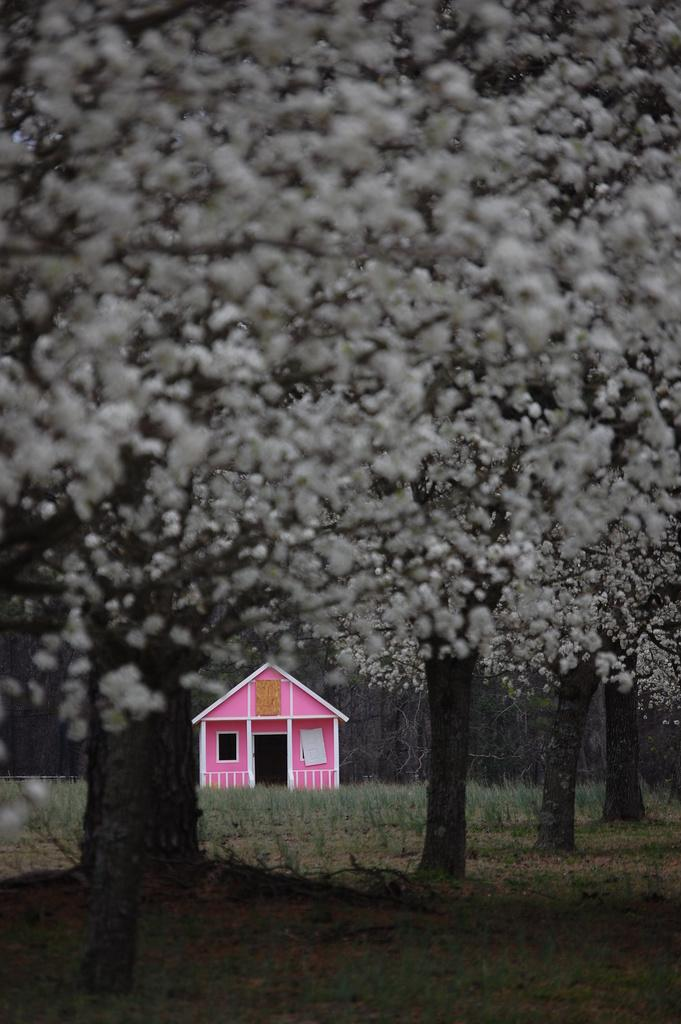What type of vegetation is in the foreground of the image? There are trees in the foreground of the image. What type of structure is visible in the background of the image? There is a house in the background of the image. What type of ground cover is visible at the bottom of the image? There is grass visible at the bottom of the image. What type of rod can be seen holding up the book in the image? There is no rod or book present in the image. How many hammers are visible in the image? There are no hammers visible in the image. 